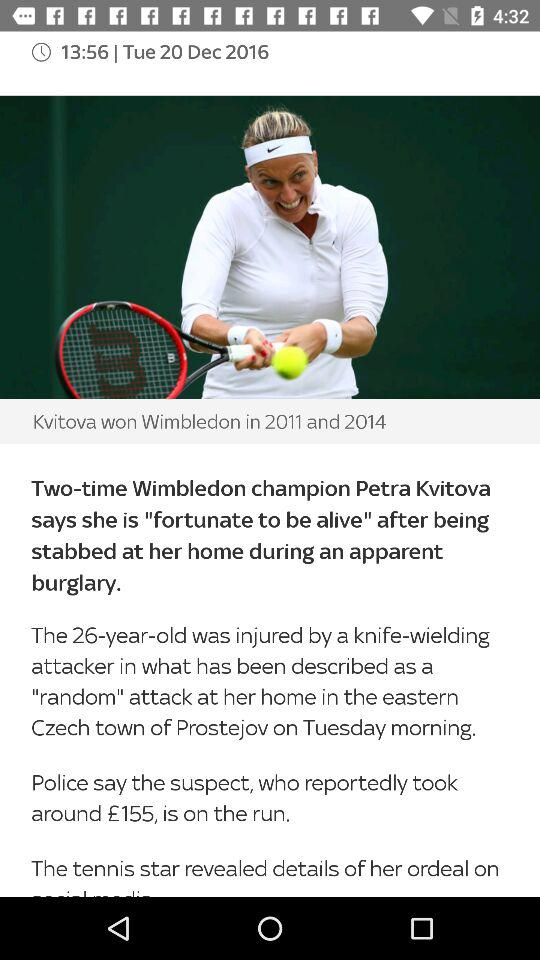How many more minutes ago was the first story published than the second story?
Answer the question using a single word or phrase. 30 